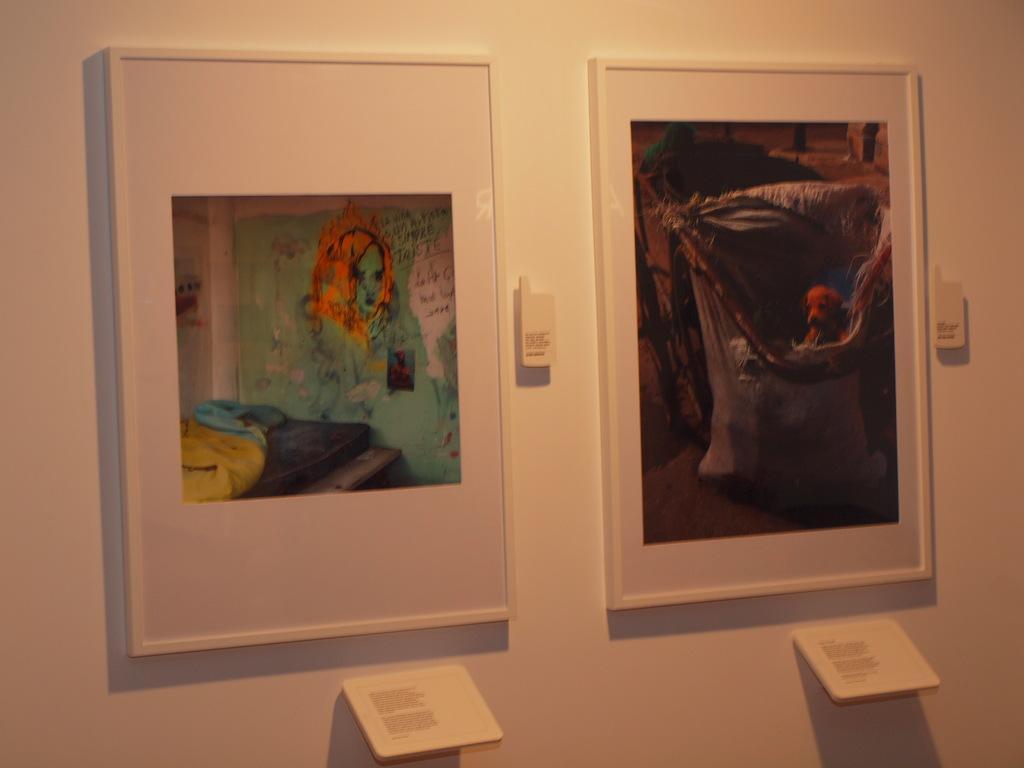How would you summarize this image in a sentence or two? In this image we can see two photo frames on the white color wall. Here we can see the small boards. 